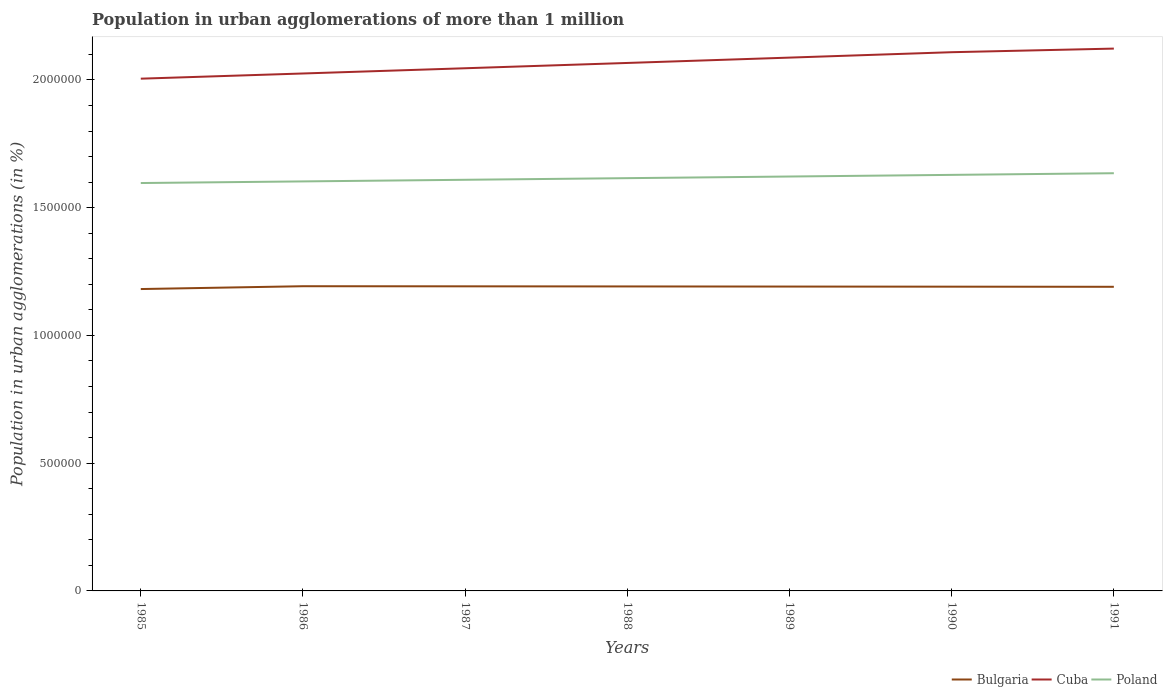Is the number of lines equal to the number of legend labels?
Offer a very short reply. Yes. Across all years, what is the maximum population in urban agglomerations in Poland?
Ensure brevity in your answer.  1.60e+06. In which year was the population in urban agglomerations in Cuba maximum?
Give a very brief answer. 1985. What is the total population in urban agglomerations in Bulgaria in the graph?
Offer a very short reply. 455. What is the difference between the highest and the second highest population in urban agglomerations in Poland?
Keep it short and to the point. 3.84e+04. Where does the legend appear in the graph?
Ensure brevity in your answer.  Bottom right. How many legend labels are there?
Give a very brief answer. 3. What is the title of the graph?
Your response must be concise. Population in urban agglomerations of more than 1 million. Does "Cuba" appear as one of the legend labels in the graph?
Make the answer very short. Yes. What is the label or title of the X-axis?
Offer a terse response. Years. What is the label or title of the Y-axis?
Give a very brief answer. Population in urban agglomerations (in %). What is the Population in urban agglomerations (in %) in Bulgaria in 1985?
Your response must be concise. 1.18e+06. What is the Population in urban agglomerations (in %) of Cuba in 1985?
Provide a succinct answer. 2.00e+06. What is the Population in urban agglomerations (in %) in Poland in 1985?
Make the answer very short. 1.60e+06. What is the Population in urban agglomerations (in %) in Bulgaria in 1986?
Offer a very short reply. 1.19e+06. What is the Population in urban agglomerations (in %) in Cuba in 1986?
Ensure brevity in your answer.  2.03e+06. What is the Population in urban agglomerations (in %) of Poland in 1986?
Provide a short and direct response. 1.60e+06. What is the Population in urban agglomerations (in %) in Bulgaria in 1987?
Offer a terse response. 1.19e+06. What is the Population in urban agglomerations (in %) in Cuba in 1987?
Give a very brief answer. 2.05e+06. What is the Population in urban agglomerations (in %) of Poland in 1987?
Your response must be concise. 1.61e+06. What is the Population in urban agglomerations (in %) in Bulgaria in 1988?
Your answer should be very brief. 1.19e+06. What is the Population in urban agglomerations (in %) of Cuba in 1988?
Offer a terse response. 2.07e+06. What is the Population in urban agglomerations (in %) of Poland in 1988?
Provide a succinct answer. 1.62e+06. What is the Population in urban agglomerations (in %) in Bulgaria in 1989?
Give a very brief answer. 1.19e+06. What is the Population in urban agglomerations (in %) of Cuba in 1989?
Provide a short and direct response. 2.09e+06. What is the Population in urban agglomerations (in %) of Poland in 1989?
Your answer should be very brief. 1.62e+06. What is the Population in urban agglomerations (in %) in Bulgaria in 1990?
Give a very brief answer. 1.19e+06. What is the Population in urban agglomerations (in %) in Cuba in 1990?
Your answer should be compact. 2.11e+06. What is the Population in urban agglomerations (in %) of Poland in 1990?
Your response must be concise. 1.63e+06. What is the Population in urban agglomerations (in %) of Bulgaria in 1991?
Your response must be concise. 1.19e+06. What is the Population in urban agglomerations (in %) in Cuba in 1991?
Your response must be concise. 2.12e+06. What is the Population in urban agglomerations (in %) of Poland in 1991?
Your answer should be compact. 1.63e+06. Across all years, what is the maximum Population in urban agglomerations (in %) in Bulgaria?
Make the answer very short. 1.19e+06. Across all years, what is the maximum Population in urban agglomerations (in %) in Cuba?
Give a very brief answer. 2.12e+06. Across all years, what is the maximum Population in urban agglomerations (in %) in Poland?
Make the answer very short. 1.63e+06. Across all years, what is the minimum Population in urban agglomerations (in %) in Bulgaria?
Offer a very short reply. 1.18e+06. Across all years, what is the minimum Population in urban agglomerations (in %) of Cuba?
Provide a succinct answer. 2.00e+06. Across all years, what is the minimum Population in urban agglomerations (in %) of Poland?
Ensure brevity in your answer.  1.60e+06. What is the total Population in urban agglomerations (in %) of Bulgaria in the graph?
Ensure brevity in your answer.  8.33e+06. What is the total Population in urban agglomerations (in %) of Cuba in the graph?
Your answer should be very brief. 1.45e+07. What is the total Population in urban agglomerations (in %) in Poland in the graph?
Provide a short and direct response. 1.13e+07. What is the difference between the Population in urban agglomerations (in %) of Bulgaria in 1985 and that in 1986?
Provide a short and direct response. -1.11e+04. What is the difference between the Population in urban agglomerations (in %) of Cuba in 1985 and that in 1986?
Make the answer very short. -2.03e+04. What is the difference between the Population in urban agglomerations (in %) of Poland in 1985 and that in 1986?
Make the answer very short. -6335. What is the difference between the Population in urban agglomerations (in %) in Bulgaria in 1985 and that in 1987?
Provide a short and direct response. -1.06e+04. What is the difference between the Population in urban agglomerations (in %) in Cuba in 1985 and that in 1987?
Your response must be concise. -4.08e+04. What is the difference between the Population in urban agglomerations (in %) in Poland in 1985 and that in 1987?
Offer a terse response. -1.27e+04. What is the difference between the Population in urban agglomerations (in %) in Bulgaria in 1985 and that in 1988?
Ensure brevity in your answer.  -1.02e+04. What is the difference between the Population in urban agglomerations (in %) of Cuba in 1985 and that in 1988?
Offer a very short reply. -6.16e+04. What is the difference between the Population in urban agglomerations (in %) of Poland in 1985 and that in 1988?
Ensure brevity in your answer.  -1.91e+04. What is the difference between the Population in urban agglomerations (in %) of Bulgaria in 1985 and that in 1989?
Offer a terse response. -9722. What is the difference between the Population in urban agglomerations (in %) of Cuba in 1985 and that in 1989?
Give a very brief answer. -8.24e+04. What is the difference between the Population in urban agglomerations (in %) of Poland in 1985 and that in 1989?
Ensure brevity in your answer.  -2.55e+04. What is the difference between the Population in urban agglomerations (in %) of Bulgaria in 1985 and that in 1990?
Your answer should be very brief. -9268. What is the difference between the Population in urban agglomerations (in %) of Cuba in 1985 and that in 1990?
Offer a terse response. -1.04e+05. What is the difference between the Population in urban agglomerations (in %) in Poland in 1985 and that in 1990?
Give a very brief answer. -3.19e+04. What is the difference between the Population in urban agglomerations (in %) in Bulgaria in 1985 and that in 1991?
Ensure brevity in your answer.  -8815. What is the difference between the Population in urban agglomerations (in %) in Cuba in 1985 and that in 1991?
Offer a very short reply. -1.18e+05. What is the difference between the Population in urban agglomerations (in %) in Poland in 1985 and that in 1991?
Keep it short and to the point. -3.84e+04. What is the difference between the Population in urban agglomerations (in %) in Bulgaria in 1986 and that in 1987?
Offer a very short reply. 454. What is the difference between the Population in urban agglomerations (in %) of Cuba in 1986 and that in 1987?
Your answer should be very brief. -2.05e+04. What is the difference between the Population in urban agglomerations (in %) in Poland in 1986 and that in 1987?
Your answer should be very brief. -6361. What is the difference between the Population in urban agglomerations (in %) of Bulgaria in 1986 and that in 1988?
Your response must be concise. 909. What is the difference between the Population in urban agglomerations (in %) in Cuba in 1986 and that in 1988?
Make the answer very short. -4.13e+04. What is the difference between the Population in urban agglomerations (in %) in Poland in 1986 and that in 1988?
Provide a succinct answer. -1.28e+04. What is the difference between the Population in urban agglomerations (in %) in Bulgaria in 1986 and that in 1989?
Provide a succinct answer. 1362. What is the difference between the Population in urban agglomerations (in %) in Cuba in 1986 and that in 1989?
Your response must be concise. -6.21e+04. What is the difference between the Population in urban agglomerations (in %) of Poland in 1986 and that in 1989?
Offer a very short reply. -1.92e+04. What is the difference between the Population in urban agglomerations (in %) in Bulgaria in 1986 and that in 1990?
Ensure brevity in your answer.  1816. What is the difference between the Population in urban agglomerations (in %) in Cuba in 1986 and that in 1990?
Your answer should be very brief. -8.33e+04. What is the difference between the Population in urban agglomerations (in %) in Poland in 1986 and that in 1990?
Offer a very short reply. -2.56e+04. What is the difference between the Population in urban agglomerations (in %) of Bulgaria in 1986 and that in 1991?
Make the answer very short. 2269. What is the difference between the Population in urban agglomerations (in %) in Cuba in 1986 and that in 1991?
Keep it short and to the point. -9.74e+04. What is the difference between the Population in urban agglomerations (in %) in Poland in 1986 and that in 1991?
Your response must be concise. -3.21e+04. What is the difference between the Population in urban agglomerations (in %) of Bulgaria in 1987 and that in 1988?
Provide a succinct answer. 455. What is the difference between the Population in urban agglomerations (in %) of Cuba in 1987 and that in 1988?
Make the answer very short. -2.07e+04. What is the difference between the Population in urban agglomerations (in %) of Poland in 1987 and that in 1988?
Provide a succinct answer. -6394. What is the difference between the Population in urban agglomerations (in %) of Bulgaria in 1987 and that in 1989?
Offer a terse response. 908. What is the difference between the Population in urban agglomerations (in %) of Cuba in 1987 and that in 1989?
Offer a very short reply. -4.16e+04. What is the difference between the Population in urban agglomerations (in %) of Poland in 1987 and that in 1989?
Your answer should be compact. -1.28e+04. What is the difference between the Population in urban agglomerations (in %) of Bulgaria in 1987 and that in 1990?
Provide a short and direct response. 1362. What is the difference between the Population in urban agglomerations (in %) in Cuba in 1987 and that in 1990?
Ensure brevity in your answer.  -6.28e+04. What is the difference between the Population in urban agglomerations (in %) of Poland in 1987 and that in 1990?
Your answer should be compact. -1.92e+04. What is the difference between the Population in urban agglomerations (in %) of Bulgaria in 1987 and that in 1991?
Make the answer very short. 1815. What is the difference between the Population in urban agglomerations (in %) in Cuba in 1987 and that in 1991?
Make the answer very short. -7.69e+04. What is the difference between the Population in urban agglomerations (in %) in Poland in 1987 and that in 1991?
Ensure brevity in your answer.  -2.57e+04. What is the difference between the Population in urban agglomerations (in %) of Bulgaria in 1988 and that in 1989?
Make the answer very short. 453. What is the difference between the Population in urban agglomerations (in %) of Cuba in 1988 and that in 1989?
Offer a very short reply. -2.09e+04. What is the difference between the Population in urban agglomerations (in %) in Poland in 1988 and that in 1989?
Give a very brief answer. -6402. What is the difference between the Population in urban agglomerations (in %) of Bulgaria in 1988 and that in 1990?
Give a very brief answer. 907. What is the difference between the Population in urban agglomerations (in %) of Cuba in 1988 and that in 1990?
Ensure brevity in your answer.  -4.20e+04. What is the difference between the Population in urban agglomerations (in %) of Poland in 1988 and that in 1990?
Provide a short and direct response. -1.28e+04. What is the difference between the Population in urban agglomerations (in %) of Bulgaria in 1988 and that in 1991?
Your answer should be very brief. 1360. What is the difference between the Population in urban agglomerations (in %) of Cuba in 1988 and that in 1991?
Provide a short and direct response. -5.62e+04. What is the difference between the Population in urban agglomerations (in %) in Poland in 1988 and that in 1991?
Give a very brief answer. -1.93e+04. What is the difference between the Population in urban agglomerations (in %) of Bulgaria in 1989 and that in 1990?
Give a very brief answer. 454. What is the difference between the Population in urban agglomerations (in %) in Cuba in 1989 and that in 1990?
Give a very brief answer. -2.11e+04. What is the difference between the Population in urban agglomerations (in %) of Poland in 1989 and that in 1990?
Make the answer very short. -6436. What is the difference between the Population in urban agglomerations (in %) in Bulgaria in 1989 and that in 1991?
Your answer should be very brief. 907. What is the difference between the Population in urban agglomerations (in %) of Cuba in 1989 and that in 1991?
Your answer should be very brief. -3.53e+04. What is the difference between the Population in urban agglomerations (in %) in Poland in 1989 and that in 1991?
Offer a terse response. -1.29e+04. What is the difference between the Population in urban agglomerations (in %) of Bulgaria in 1990 and that in 1991?
Provide a short and direct response. 453. What is the difference between the Population in urban agglomerations (in %) of Cuba in 1990 and that in 1991?
Your response must be concise. -1.41e+04. What is the difference between the Population in urban agglomerations (in %) in Poland in 1990 and that in 1991?
Your answer should be compact. -6462. What is the difference between the Population in urban agglomerations (in %) in Bulgaria in 1985 and the Population in urban agglomerations (in %) in Cuba in 1986?
Offer a terse response. -8.44e+05. What is the difference between the Population in urban agglomerations (in %) of Bulgaria in 1985 and the Population in urban agglomerations (in %) of Poland in 1986?
Keep it short and to the point. -4.21e+05. What is the difference between the Population in urban agglomerations (in %) of Cuba in 1985 and the Population in urban agglomerations (in %) of Poland in 1986?
Offer a very short reply. 4.02e+05. What is the difference between the Population in urban agglomerations (in %) in Bulgaria in 1985 and the Population in urban agglomerations (in %) in Cuba in 1987?
Provide a succinct answer. -8.64e+05. What is the difference between the Population in urban agglomerations (in %) of Bulgaria in 1985 and the Population in urban agglomerations (in %) of Poland in 1987?
Ensure brevity in your answer.  -4.28e+05. What is the difference between the Population in urban agglomerations (in %) of Cuba in 1985 and the Population in urban agglomerations (in %) of Poland in 1987?
Offer a very short reply. 3.96e+05. What is the difference between the Population in urban agglomerations (in %) in Bulgaria in 1985 and the Population in urban agglomerations (in %) in Cuba in 1988?
Your answer should be compact. -8.85e+05. What is the difference between the Population in urban agglomerations (in %) of Bulgaria in 1985 and the Population in urban agglomerations (in %) of Poland in 1988?
Your answer should be compact. -4.34e+05. What is the difference between the Population in urban agglomerations (in %) of Cuba in 1985 and the Population in urban agglomerations (in %) of Poland in 1988?
Your response must be concise. 3.89e+05. What is the difference between the Population in urban agglomerations (in %) in Bulgaria in 1985 and the Population in urban agglomerations (in %) in Cuba in 1989?
Provide a short and direct response. -9.06e+05. What is the difference between the Population in urban agglomerations (in %) in Bulgaria in 1985 and the Population in urban agglomerations (in %) in Poland in 1989?
Keep it short and to the point. -4.40e+05. What is the difference between the Population in urban agglomerations (in %) of Cuba in 1985 and the Population in urban agglomerations (in %) of Poland in 1989?
Ensure brevity in your answer.  3.83e+05. What is the difference between the Population in urban agglomerations (in %) of Bulgaria in 1985 and the Population in urban agglomerations (in %) of Cuba in 1990?
Offer a terse response. -9.27e+05. What is the difference between the Population in urban agglomerations (in %) in Bulgaria in 1985 and the Population in urban agglomerations (in %) in Poland in 1990?
Your answer should be very brief. -4.47e+05. What is the difference between the Population in urban agglomerations (in %) in Cuba in 1985 and the Population in urban agglomerations (in %) in Poland in 1990?
Offer a very short reply. 3.76e+05. What is the difference between the Population in urban agglomerations (in %) of Bulgaria in 1985 and the Population in urban agglomerations (in %) of Cuba in 1991?
Your response must be concise. -9.41e+05. What is the difference between the Population in urban agglomerations (in %) of Bulgaria in 1985 and the Population in urban agglomerations (in %) of Poland in 1991?
Make the answer very short. -4.53e+05. What is the difference between the Population in urban agglomerations (in %) of Cuba in 1985 and the Population in urban agglomerations (in %) of Poland in 1991?
Offer a terse response. 3.70e+05. What is the difference between the Population in urban agglomerations (in %) of Bulgaria in 1986 and the Population in urban agglomerations (in %) of Cuba in 1987?
Offer a terse response. -8.53e+05. What is the difference between the Population in urban agglomerations (in %) of Bulgaria in 1986 and the Population in urban agglomerations (in %) of Poland in 1987?
Provide a succinct answer. -4.17e+05. What is the difference between the Population in urban agglomerations (in %) in Cuba in 1986 and the Population in urban agglomerations (in %) in Poland in 1987?
Your answer should be very brief. 4.16e+05. What is the difference between the Population in urban agglomerations (in %) in Bulgaria in 1986 and the Population in urban agglomerations (in %) in Cuba in 1988?
Your response must be concise. -8.74e+05. What is the difference between the Population in urban agglomerations (in %) of Bulgaria in 1986 and the Population in urban agglomerations (in %) of Poland in 1988?
Give a very brief answer. -4.23e+05. What is the difference between the Population in urban agglomerations (in %) in Cuba in 1986 and the Population in urban agglomerations (in %) in Poland in 1988?
Ensure brevity in your answer.  4.10e+05. What is the difference between the Population in urban agglomerations (in %) of Bulgaria in 1986 and the Population in urban agglomerations (in %) of Cuba in 1989?
Ensure brevity in your answer.  -8.95e+05. What is the difference between the Population in urban agglomerations (in %) in Bulgaria in 1986 and the Population in urban agglomerations (in %) in Poland in 1989?
Provide a short and direct response. -4.29e+05. What is the difference between the Population in urban agglomerations (in %) in Cuba in 1986 and the Population in urban agglomerations (in %) in Poland in 1989?
Give a very brief answer. 4.03e+05. What is the difference between the Population in urban agglomerations (in %) of Bulgaria in 1986 and the Population in urban agglomerations (in %) of Cuba in 1990?
Give a very brief answer. -9.16e+05. What is the difference between the Population in urban agglomerations (in %) in Bulgaria in 1986 and the Population in urban agglomerations (in %) in Poland in 1990?
Keep it short and to the point. -4.36e+05. What is the difference between the Population in urban agglomerations (in %) of Cuba in 1986 and the Population in urban agglomerations (in %) of Poland in 1990?
Keep it short and to the point. 3.97e+05. What is the difference between the Population in urban agglomerations (in %) in Bulgaria in 1986 and the Population in urban agglomerations (in %) in Cuba in 1991?
Make the answer very short. -9.30e+05. What is the difference between the Population in urban agglomerations (in %) of Bulgaria in 1986 and the Population in urban agglomerations (in %) of Poland in 1991?
Offer a very short reply. -4.42e+05. What is the difference between the Population in urban agglomerations (in %) in Cuba in 1986 and the Population in urban agglomerations (in %) in Poland in 1991?
Your answer should be compact. 3.90e+05. What is the difference between the Population in urban agglomerations (in %) of Bulgaria in 1987 and the Population in urban agglomerations (in %) of Cuba in 1988?
Offer a very short reply. -8.74e+05. What is the difference between the Population in urban agglomerations (in %) in Bulgaria in 1987 and the Population in urban agglomerations (in %) in Poland in 1988?
Give a very brief answer. -4.23e+05. What is the difference between the Population in urban agglomerations (in %) in Cuba in 1987 and the Population in urban agglomerations (in %) in Poland in 1988?
Your answer should be compact. 4.30e+05. What is the difference between the Population in urban agglomerations (in %) of Bulgaria in 1987 and the Population in urban agglomerations (in %) of Cuba in 1989?
Offer a very short reply. -8.95e+05. What is the difference between the Population in urban agglomerations (in %) in Bulgaria in 1987 and the Population in urban agglomerations (in %) in Poland in 1989?
Provide a succinct answer. -4.30e+05. What is the difference between the Population in urban agglomerations (in %) in Cuba in 1987 and the Population in urban agglomerations (in %) in Poland in 1989?
Provide a succinct answer. 4.24e+05. What is the difference between the Population in urban agglomerations (in %) in Bulgaria in 1987 and the Population in urban agglomerations (in %) in Cuba in 1990?
Offer a terse response. -9.16e+05. What is the difference between the Population in urban agglomerations (in %) in Bulgaria in 1987 and the Population in urban agglomerations (in %) in Poland in 1990?
Offer a very short reply. -4.36e+05. What is the difference between the Population in urban agglomerations (in %) in Cuba in 1987 and the Population in urban agglomerations (in %) in Poland in 1990?
Provide a succinct answer. 4.17e+05. What is the difference between the Population in urban agglomerations (in %) in Bulgaria in 1987 and the Population in urban agglomerations (in %) in Cuba in 1991?
Your answer should be compact. -9.30e+05. What is the difference between the Population in urban agglomerations (in %) in Bulgaria in 1987 and the Population in urban agglomerations (in %) in Poland in 1991?
Ensure brevity in your answer.  -4.43e+05. What is the difference between the Population in urban agglomerations (in %) in Cuba in 1987 and the Population in urban agglomerations (in %) in Poland in 1991?
Ensure brevity in your answer.  4.11e+05. What is the difference between the Population in urban agglomerations (in %) in Bulgaria in 1988 and the Population in urban agglomerations (in %) in Cuba in 1989?
Offer a very short reply. -8.96e+05. What is the difference between the Population in urban agglomerations (in %) of Bulgaria in 1988 and the Population in urban agglomerations (in %) of Poland in 1989?
Make the answer very short. -4.30e+05. What is the difference between the Population in urban agglomerations (in %) of Cuba in 1988 and the Population in urban agglomerations (in %) of Poland in 1989?
Your answer should be very brief. 4.44e+05. What is the difference between the Population in urban agglomerations (in %) of Bulgaria in 1988 and the Population in urban agglomerations (in %) of Cuba in 1990?
Offer a terse response. -9.17e+05. What is the difference between the Population in urban agglomerations (in %) of Bulgaria in 1988 and the Population in urban agglomerations (in %) of Poland in 1990?
Offer a terse response. -4.37e+05. What is the difference between the Population in urban agglomerations (in %) in Cuba in 1988 and the Population in urban agglomerations (in %) in Poland in 1990?
Offer a very short reply. 4.38e+05. What is the difference between the Population in urban agglomerations (in %) of Bulgaria in 1988 and the Population in urban agglomerations (in %) of Cuba in 1991?
Ensure brevity in your answer.  -9.31e+05. What is the difference between the Population in urban agglomerations (in %) of Bulgaria in 1988 and the Population in urban agglomerations (in %) of Poland in 1991?
Provide a succinct answer. -4.43e+05. What is the difference between the Population in urban agglomerations (in %) of Cuba in 1988 and the Population in urban agglomerations (in %) of Poland in 1991?
Ensure brevity in your answer.  4.32e+05. What is the difference between the Population in urban agglomerations (in %) in Bulgaria in 1989 and the Population in urban agglomerations (in %) in Cuba in 1990?
Provide a succinct answer. -9.17e+05. What is the difference between the Population in urban agglomerations (in %) of Bulgaria in 1989 and the Population in urban agglomerations (in %) of Poland in 1990?
Keep it short and to the point. -4.37e+05. What is the difference between the Population in urban agglomerations (in %) in Cuba in 1989 and the Population in urban agglomerations (in %) in Poland in 1990?
Your answer should be compact. 4.59e+05. What is the difference between the Population in urban agglomerations (in %) of Bulgaria in 1989 and the Population in urban agglomerations (in %) of Cuba in 1991?
Provide a succinct answer. -9.31e+05. What is the difference between the Population in urban agglomerations (in %) of Bulgaria in 1989 and the Population in urban agglomerations (in %) of Poland in 1991?
Keep it short and to the point. -4.44e+05. What is the difference between the Population in urban agglomerations (in %) of Cuba in 1989 and the Population in urban agglomerations (in %) of Poland in 1991?
Your response must be concise. 4.52e+05. What is the difference between the Population in urban agglomerations (in %) in Bulgaria in 1990 and the Population in urban agglomerations (in %) in Cuba in 1991?
Keep it short and to the point. -9.32e+05. What is the difference between the Population in urban agglomerations (in %) of Bulgaria in 1990 and the Population in urban agglomerations (in %) of Poland in 1991?
Your response must be concise. -4.44e+05. What is the difference between the Population in urban agglomerations (in %) of Cuba in 1990 and the Population in urban agglomerations (in %) of Poland in 1991?
Your response must be concise. 4.74e+05. What is the average Population in urban agglomerations (in %) in Bulgaria per year?
Make the answer very short. 1.19e+06. What is the average Population in urban agglomerations (in %) in Cuba per year?
Your response must be concise. 2.07e+06. What is the average Population in urban agglomerations (in %) of Poland per year?
Ensure brevity in your answer.  1.62e+06. In the year 1985, what is the difference between the Population in urban agglomerations (in %) in Bulgaria and Population in urban agglomerations (in %) in Cuba?
Keep it short and to the point. -8.23e+05. In the year 1985, what is the difference between the Population in urban agglomerations (in %) of Bulgaria and Population in urban agglomerations (in %) of Poland?
Provide a short and direct response. -4.15e+05. In the year 1985, what is the difference between the Population in urban agglomerations (in %) in Cuba and Population in urban agglomerations (in %) in Poland?
Make the answer very short. 4.08e+05. In the year 1986, what is the difference between the Population in urban agglomerations (in %) of Bulgaria and Population in urban agglomerations (in %) of Cuba?
Provide a short and direct response. -8.33e+05. In the year 1986, what is the difference between the Population in urban agglomerations (in %) in Bulgaria and Population in urban agglomerations (in %) in Poland?
Offer a very short reply. -4.10e+05. In the year 1986, what is the difference between the Population in urban agglomerations (in %) of Cuba and Population in urban agglomerations (in %) of Poland?
Offer a terse response. 4.22e+05. In the year 1987, what is the difference between the Population in urban agglomerations (in %) of Bulgaria and Population in urban agglomerations (in %) of Cuba?
Provide a succinct answer. -8.54e+05. In the year 1987, what is the difference between the Population in urban agglomerations (in %) of Bulgaria and Population in urban agglomerations (in %) of Poland?
Ensure brevity in your answer.  -4.17e+05. In the year 1987, what is the difference between the Population in urban agglomerations (in %) of Cuba and Population in urban agglomerations (in %) of Poland?
Keep it short and to the point. 4.37e+05. In the year 1988, what is the difference between the Population in urban agglomerations (in %) in Bulgaria and Population in urban agglomerations (in %) in Cuba?
Offer a terse response. -8.75e+05. In the year 1988, what is the difference between the Population in urban agglomerations (in %) of Bulgaria and Population in urban agglomerations (in %) of Poland?
Provide a succinct answer. -4.24e+05. In the year 1988, what is the difference between the Population in urban agglomerations (in %) of Cuba and Population in urban agglomerations (in %) of Poland?
Your answer should be very brief. 4.51e+05. In the year 1989, what is the difference between the Population in urban agglomerations (in %) in Bulgaria and Population in urban agglomerations (in %) in Cuba?
Offer a terse response. -8.96e+05. In the year 1989, what is the difference between the Population in urban agglomerations (in %) in Bulgaria and Population in urban agglomerations (in %) in Poland?
Provide a succinct answer. -4.31e+05. In the year 1989, what is the difference between the Population in urban agglomerations (in %) in Cuba and Population in urban agglomerations (in %) in Poland?
Your answer should be very brief. 4.65e+05. In the year 1990, what is the difference between the Population in urban agglomerations (in %) of Bulgaria and Population in urban agglomerations (in %) of Cuba?
Your answer should be very brief. -9.18e+05. In the year 1990, what is the difference between the Population in urban agglomerations (in %) in Bulgaria and Population in urban agglomerations (in %) in Poland?
Make the answer very short. -4.38e+05. In the year 1990, what is the difference between the Population in urban agglomerations (in %) in Cuba and Population in urban agglomerations (in %) in Poland?
Offer a terse response. 4.80e+05. In the year 1991, what is the difference between the Population in urban agglomerations (in %) in Bulgaria and Population in urban agglomerations (in %) in Cuba?
Provide a succinct answer. -9.32e+05. In the year 1991, what is the difference between the Population in urban agglomerations (in %) in Bulgaria and Population in urban agglomerations (in %) in Poland?
Your answer should be compact. -4.44e+05. In the year 1991, what is the difference between the Population in urban agglomerations (in %) of Cuba and Population in urban agglomerations (in %) of Poland?
Offer a terse response. 4.88e+05. What is the ratio of the Population in urban agglomerations (in %) in Cuba in 1985 to that in 1986?
Your response must be concise. 0.99. What is the ratio of the Population in urban agglomerations (in %) in Poland in 1985 to that in 1986?
Keep it short and to the point. 1. What is the ratio of the Population in urban agglomerations (in %) of Bulgaria in 1985 to that in 1987?
Provide a short and direct response. 0.99. What is the ratio of the Population in urban agglomerations (in %) of Cuba in 1985 to that in 1988?
Provide a short and direct response. 0.97. What is the ratio of the Population in urban agglomerations (in %) of Poland in 1985 to that in 1988?
Provide a short and direct response. 0.99. What is the ratio of the Population in urban agglomerations (in %) in Cuba in 1985 to that in 1989?
Offer a very short reply. 0.96. What is the ratio of the Population in urban agglomerations (in %) of Poland in 1985 to that in 1989?
Give a very brief answer. 0.98. What is the ratio of the Population in urban agglomerations (in %) of Cuba in 1985 to that in 1990?
Your response must be concise. 0.95. What is the ratio of the Population in urban agglomerations (in %) of Poland in 1985 to that in 1990?
Offer a very short reply. 0.98. What is the ratio of the Population in urban agglomerations (in %) of Cuba in 1985 to that in 1991?
Your answer should be compact. 0.94. What is the ratio of the Population in urban agglomerations (in %) in Poland in 1985 to that in 1991?
Offer a very short reply. 0.98. What is the ratio of the Population in urban agglomerations (in %) in Cuba in 1986 to that in 1988?
Your answer should be very brief. 0.98. What is the ratio of the Population in urban agglomerations (in %) of Poland in 1986 to that in 1988?
Ensure brevity in your answer.  0.99. What is the ratio of the Population in urban agglomerations (in %) in Cuba in 1986 to that in 1989?
Give a very brief answer. 0.97. What is the ratio of the Population in urban agglomerations (in %) in Bulgaria in 1986 to that in 1990?
Provide a short and direct response. 1. What is the ratio of the Population in urban agglomerations (in %) in Cuba in 1986 to that in 1990?
Provide a succinct answer. 0.96. What is the ratio of the Population in urban agglomerations (in %) of Poland in 1986 to that in 1990?
Your answer should be compact. 0.98. What is the ratio of the Population in urban agglomerations (in %) in Bulgaria in 1986 to that in 1991?
Provide a short and direct response. 1. What is the ratio of the Population in urban agglomerations (in %) in Cuba in 1986 to that in 1991?
Make the answer very short. 0.95. What is the ratio of the Population in urban agglomerations (in %) in Poland in 1986 to that in 1991?
Your answer should be very brief. 0.98. What is the ratio of the Population in urban agglomerations (in %) of Cuba in 1987 to that in 1989?
Offer a terse response. 0.98. What is the ratio of the Population in urban agglomerations (in %) of Poland in 1987 to that in 1989?
Keep it short and to the point. 0.99. What is the ratio of the Population in urban agglomerations (in %) in Cuba in 1987 to that in 1990?
Provide a short and direct response. 0.97. What is the ratio of the Population in urban agglomerations (in %) of Cuba in 1987 to that in 1991?
Make the answer very short. 0.96. What is the ratio of the Population in urban agglomerations (in %) of Poland in 1987 to that in 1991?
Your response must be concise. 0.98. What is the ratio of the Population in urban agglomerations (in %) of Cuba in 1988 to that in 1989?
Give a very brief answer. 0.99. What is the ratio of the Population in urban agglomerations (in %) in Bulgaria in 1988 to that in 1990?
Your answer should be compact. 1. What is the ratio of the Population in urban agglomerations (in %) in Cuba in 1988 to that in 1990?
Offer a very short reply. 0.98. What is the ratio of the Population in urban agglomerations (in %) of Bulgaria in 1988 to that in 1991?
Offer a very short reply. 1. What is the ratio of the Population in urban agglomerations (in %) in Cuba in 1988 to that in 1991?
Make the answer very short. 0.97. What is the ratio of the Population in urban agglomerations (in %) in Poland in 1988 to that in 1991?
Offer a very short reply. 0.99. What is the ratio of the Population in urban agglomerations (in %) of Bulgaria in 1989 to that in 1990?
Offer a terse response. 1. What is the ratio of the Population in urban agglomerations (in %) in Bulgaria in 1989 to that in 1991?
Offer a terse response. 1. What is the ratio of the Population in urban agglomerations (in %) in Cuba in 1989 to that in 1991?
Your answer should be compact. 0.98. What is the ratio of the Population in urban agglomerations (in %) of Cuba in 1990 to that in 1991?
Your response must be concise. 0.99. What is the difference between the highest and the second highest Population in urban agglomerations (in %) of Bulgaria?
Provide a succinct answer. 454. What is the difference between the highest and the second highest Population in urban agglomerations (in %) in Cuba?
Ensure brevity in your answer.  1.41e+04. What is the difference between the highest and the second highest Population in urban agglomerations (in %) of Poland?
Your answer should be compact. 6462. What is the difference between the highest and the lowest Population in urban agglomerations (in %) in Bulgaria?
Provide a short and direct response. 1.11e+04. What is the difference between the highest and the lowest Population in urban agglomerations (in %) of Cuba?
Ensure brevity in your answer.  1.18e+05. What is the difference between the highest and the lowest Population in urban agglomerations (in %) in Poland?
Offer a very short reply. 3.84e+04. 